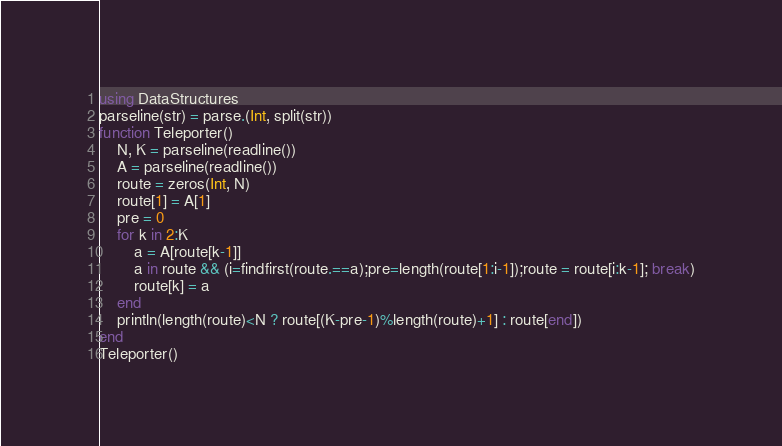<code> <loc_0><loc_0><loc_500><loc_500><_Julia_>using DataStructures
parseline(str) = parse.(Int, split(str))
function Teleporter()
    N, K = parseline(readline())
    A = parseline(readline())
    route = zeros(Int, N)
    route[1] = A[1]
    pre = 0
    for k in 2:K
        a = A[route[k-1]]
        a in route && (i=findfirst(route.==a);pre=length(route[1:i-1]);route = route[i:k-1]; break)
        route[k] = a
    end
    println(length(route)<N ? route[(K-pre-1)%length(route)+1] : route[end])
end
Teleporter()</code> 